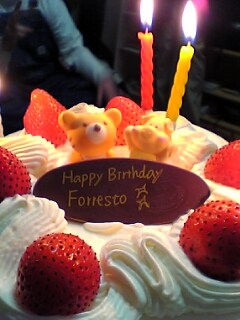Describe the objects in this image and their specific colors. I can see cake in black, maroon, tan, and darkgray tones, people in black, gray, blue, and teal tones, and teddy bear in black, red, orange, and gold tones in this image. 